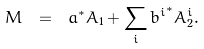<formula> <loc_0><loc_0><loc_500><loc_500>\bar { M } \ = \ a ^ { \ast } A _ { 1 } + \sum _ { i } { b ^ { i } } ^ { \ast } A _ { 2 } ^ { i } .</formula> 